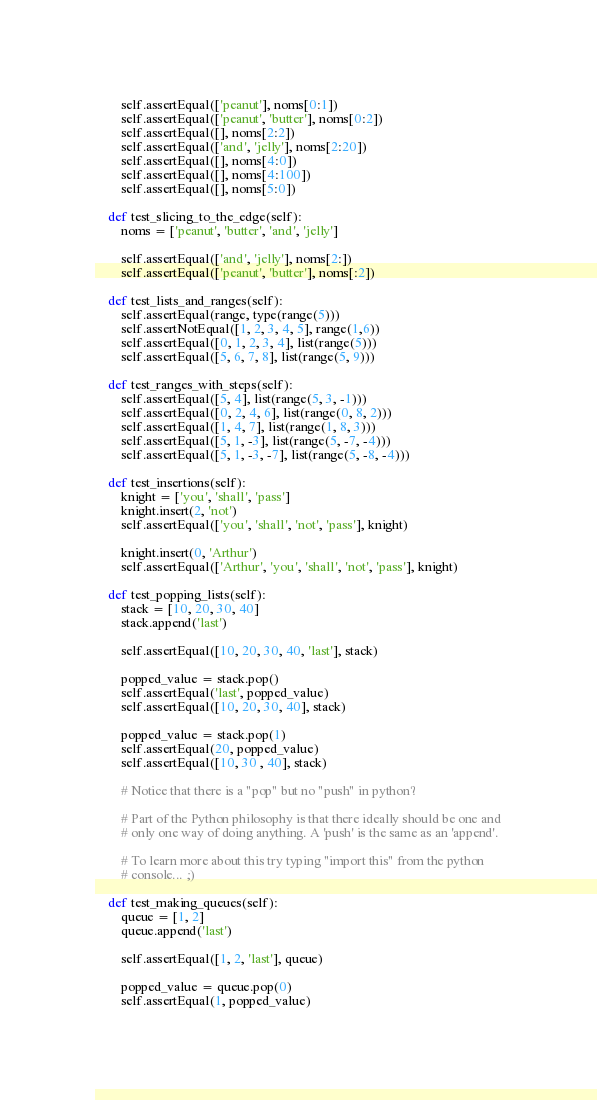<code> <loc_0><loc_0><loc_500><loc_500><_Python_>        self.assertEqual(['peanut'], noms[0:1])
        self.assertEqual(['peanut', 'butter'], noms[0:2])
        self.assertEqual([], noms[2:2])
        self.assertEqual(['and', 'jelly'], noms[2:20])
        self.assertEqual([], noms[4:0])
        self.assertEqual([], noms[4:100])
        self.assertEqual([], noms[5:0])

    def test_slicing_to_the_edge(self):
        noms = ['peanut', 'butter', 'and', 'jelly']

        self.assertEqual(['and', 'jelly'], noms[2:])
        self.assertEqual(['peanut', 'butter'], noms[:2])

    def test_lists_and_ranges(self):
        self.assertEqual(range, type(range(5)))
        self.assertNotEqual([1, 2, 3, 4, 5], range(1,6))
        self.assertEqual([0, 1, 2, 3, 4], list(range(5)))
        self.assertEqual([5, 6, 7, 8], list(range(5, 9)))

    def test_ranges_with_steps(self):
        self.assertEqual([5, 4], list(range(5, 3, -1)))
        self.assertEqual([0, 2, 4, 6], list(range(0, 8, 2)))
        self.assertEqual([1, 4, 7], list(range(1, 8, 3)))
        self.assertEqual([5, 1, -3], list(range(5, -7, -4)))
        self.assertEqual([5, 1, -3, -7], list(range(5, -8, -4)))

    def test_insertions(self):
        knight = ['you', 'shall', 'pass']
        knight.insert(2, 'not')
        self.assertEqual(['you', 'shall', 'not', 'pass'], knight)

        knight.insert(0, 'Arthur')
        self.assertEqual(['Arthur', 'you', 'shall', 'not', 'pass'], knight)

    def test_popping_lists(self):
        stack = [10, 20, 30, 40]
        stack.append('last')

        self.assertEqual([10, 20, 30, 40, 'last'], stack)

        popped_value = stack.pop()
        self.assertEqual('last', popped_value)
        self.assertEqual([10, 20, 30, 40], stack)

        popped_value = stack.pop(1)
        self.assertEqual(20, popped_value)
        self.assertEqual([10, 30 , 40], stack)

        # Notice that there is a "pop" but no "push" in python?

        # Part of the Python philosophy is that there ideally should be one and
        # only one way of doing anything. A 'push' is the same as an 'append'.

        # To learn more about this try typing "import this" from the python
        # console... ;)

    def test_making_queues(self):
        queue = [1, 2]
        queue.append('last')

        self.assertEqual([1, 2, 'last'], queue)

        popped_value = queue.pop(0)
        self.assertEqual(1, popped_value)</code> 